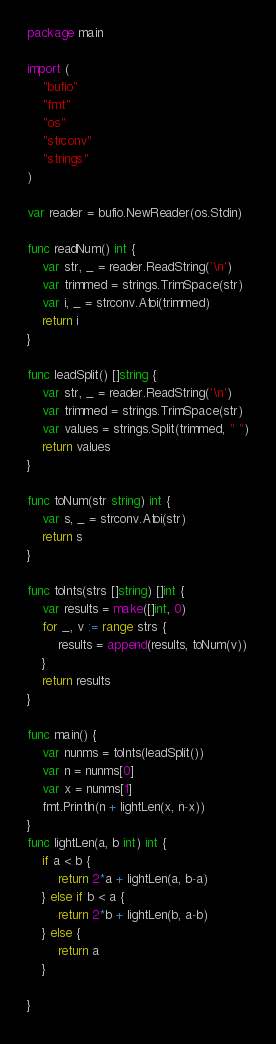Convert code to text. <code><loc_0><loc_0><loc_500><loc_500><_Go_>package main

import (
	"bufio"
	"fmt"
	"os"
	"strconv"
	"strings"
)

var reader = bufio.NewReader(os.Stdin)

func readNum() int {
	var str, _ = reader.ReadString('\n')
	var trimmed = strings.TrimSpace(str)
	var i, _ = strconv.Atoi(trimmed)
	return i
}

func leadSplit() []string {
	var str, _ = reader.ReadString('\n')
	var trimmed = strings.TrimSpace(str)
	var values = strings.Split(trimmed, " ")
	return values
}

func toNum(str string) int {
	var s, _ = strconv.Atoi(str)
	return s
}

func toInts(strs []string) []int {
	var results = make([]int, 0)
	for _, v := range strs {
		results = append(results, toNum(v))
	}
	return results
}

func main() {
	var nunms = toInts(leadSplit())
	var n = nunms[0]
	var x = nunms[1]
	fmt.Println(n + lightLen(x, n-x))
}
func lightLen(a, b int) int {
	if a < b {
		return 2*a + lightLen(a, b-a)
	} else if b < a {
		return 2*b + lightLen(b, a-b)
	} else {
		return a
	}

}
</code> 